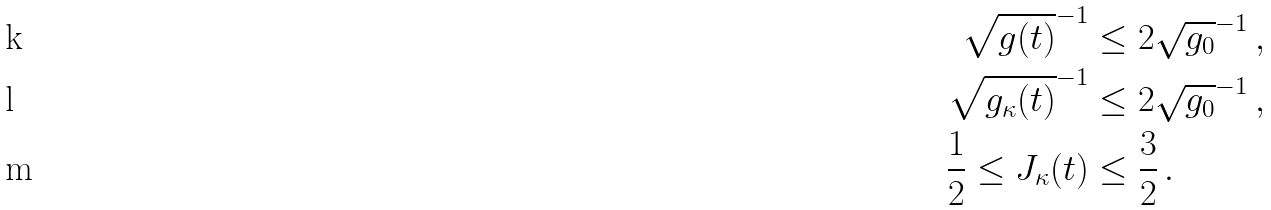<formula> <loc_0><loc_0><loc_500><loc_500>\sqrt { g ( t ) } ^ { - 1 } & \leq 2 \sqrt { g _ { 0 } } ^ { - 1 } \, , \\ \sqrt { g _ { \kappa } ( t ) } ^ { - 1 } & \leq 2 \sqrt { g _ { 0 } } ^ { - 1 } \, , \\ { \frac { 1 } { 2 } } \leq J _ { \kappa } ( t ) & \leq { \frac { 3 } { 2 } } \, .</formula> 